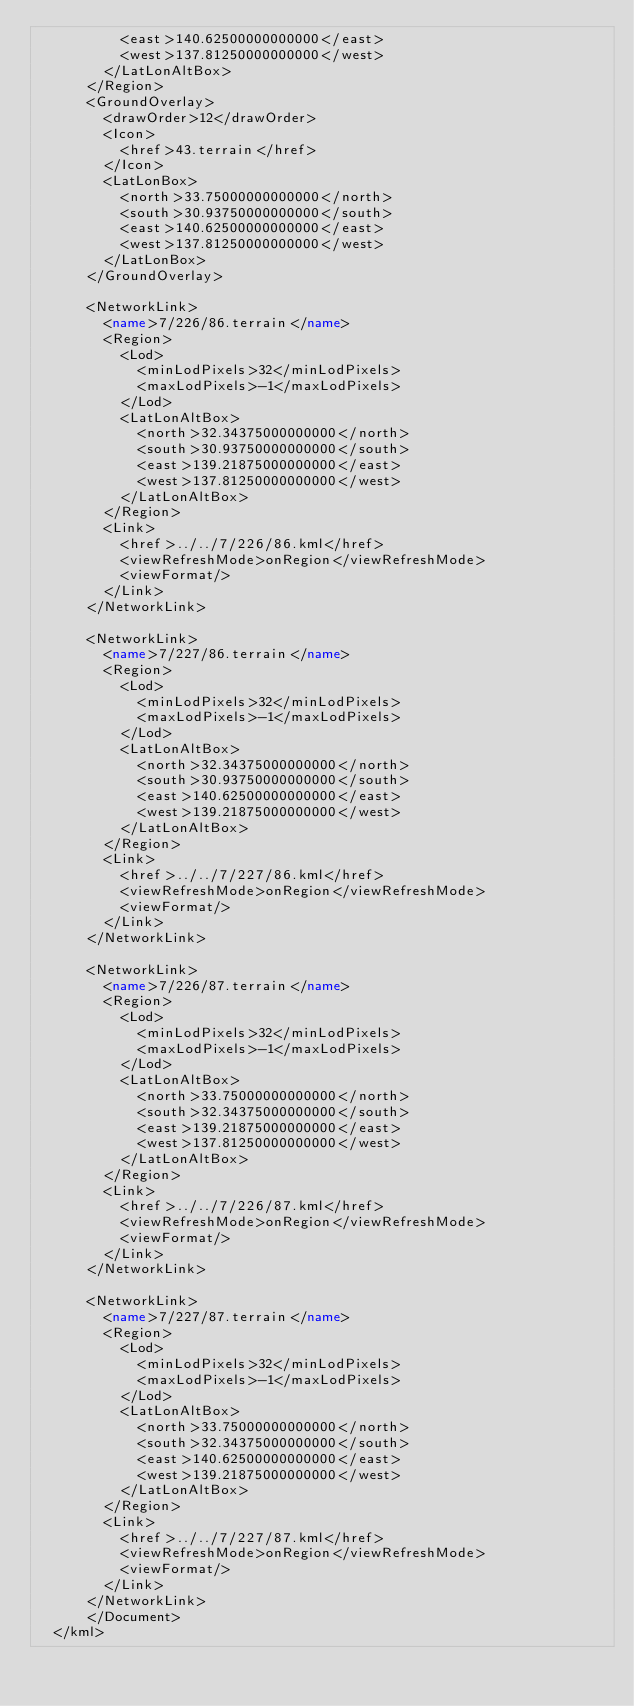Convert code to text. <code><loc_0><loc_0><loc_500><loc_500><_XML_>	        <east>140.62500000000000</east>
	        <west>137.81250000000000</west>
	      </LatLonAltBox>
	    </Region>
	    <GroundOverlay>
	      <drawOrder>12</drawOrder>
	      <Icon>
	        <href>43.terrain</href>
	      </Icon>
	      <LatLonBox>
	        <north>33.75000000000000</north>
	        <south>30.93750000000000</south>
	        <east>140.62500000000000</east>
	        <west>137.81250000000000</west>
	      </LatLonBox>
	    </GroundOverlay>
	
	    <NetworkLink>
	      <name>7/226/86.terrain</name>
	      <Region>
	        <Lod>
	          <minLodPixels>32</minLodPixels>
	          <maxLodPixels>-1</maxLodPixels>
	        </Lod>
	        <LatLonAltBox>
	          <north>32.34375000000000</north>
	          <south>30.93750000000000</south>
	          <east>139.21875000000000</east>
	          <west>137.81250000000000</west>
	        </LatLonAltBox>
	      </Region>
	      <Link>
	        <href>../../7/226/86.kml</href>
	        <viewRefreshMode>onRegion</viewRefreshMode>
	        <viewFormat/>
	      </Link>
	    </NetworkLink>
	
	    <NetworkLink>
	      <name>7/227/86.terrain</name>
	      <Region>
	        <Lod>
	          <minLodPixels>32</minLodPixels>
	          <maxLodPixels>-1</maxLodPixels>
	        </Lod>
	        <LatLonAltBox>
	          <north>32.34375000000000</north>
	          <south>30.93750000000000</south>
	          <east>140.62500000000000</east>
	          <west>139.21875000000000</west>
	        </LatLonAltBox>
	      </Region>
	      <Link>
	        <href>../../7/227/86.kml</href>
	        <viewRefreshMode>onRegion</viewRefreshMode>
	        <viewFormat/>
	      </Link>
	    </NetworkLink>
	
	    <NetworkLink>
	      <name>7/226/87.terrain</name>
	      <Region>
	        <Lod>
	          <minLodPixels>32</minLodPixels>
	          <maxLodPixels>-1</maxLodPixels>
	        </Lod>
	        <LatLonAltBox>
	          <north>33.75000000000000</north>
	          <south>32.34375000000000</south>
	          <east>139.21875000000000</east>
	          <west>137.81250000000000</west>
	        </LatLonAltBox>
	      </Region>
	      <Link>
	        <href>../../7/226/87.kml</href>
	        <viewRefreshMode>onRegion</viewRefreshMode>
	        <viewFormat/>
	      </Link>
	    </NetworkLink>
	
	    <NetworkLink>
	      <name>7/227/87.terrain</name>
	      <Region>
	        <Lod>
	          <minLodPixels>32</minLodPixels>
	          <maxLodPixels>-1</maxLodPixels>
	        </Lod>
	        <LatLonAltBox>
	          <north>33.75000000000000</north>
	          <south>32.34375000000000</south>
	          <east>140.62500000000000</east>
	          <west>139.21875000000000</west>
	        </LatLonAltBox>
	      </Region>
	      <Link>
	        <href>../../7/227/87.kml</href>
	        <viewRefreshMode>onRegion</viewRefreshMode>
	        <viewFormat/>
	      </Link>
	    </NetworkLink>
		  </Document>
	</kml>
	</code> 